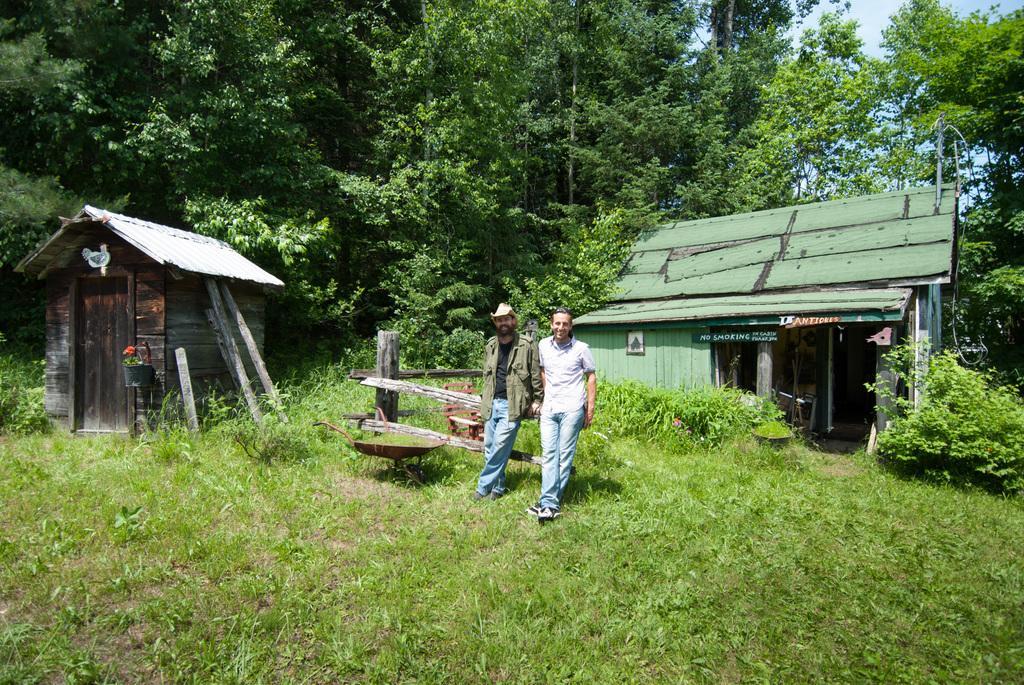Can you describe this image briefly? In this picture we can see two men standing on the ground and smiling, houses, trees, grass, house plant, sticks, frame on the wall and some objects and in the background we can see the sky. 